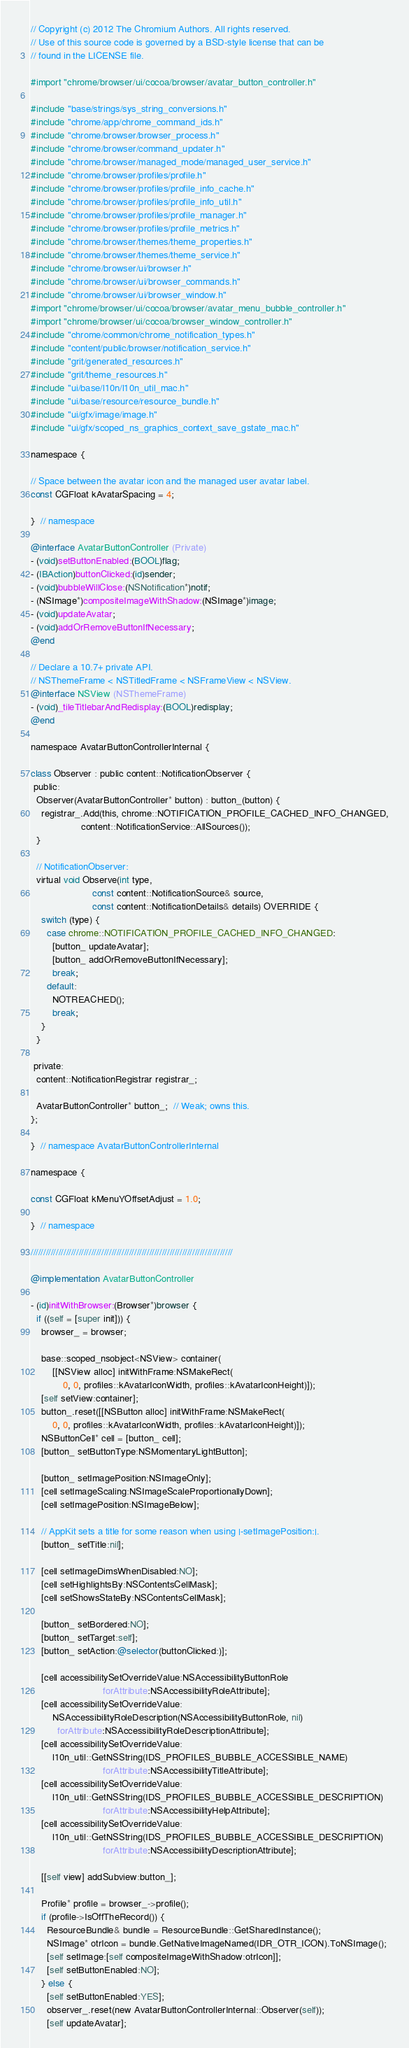<code> <loc_0><loc_0><loc_500><loc_500><_ObjectiveC_>// Copyright (c) 2012 The Chromium Authors. All rights reserved.
// Use of this source code is governed by a BSD-style license that can be
// found in the LICENSE file.

#import "chrome/browser/ui/cocoa/browser/avatar_button_controller.h"

#include "base/strings/sys_string_conversions.h"
#include "chrome/app/chrome_command_ids.h"
#include "chrome/browser/browser_process.h"
#include "chrome/browser/command_updater.h"
#include "chrome/browser/managed_mode/managed_user_service.h"
#include "chrome/browser/profiles/profile.h"
#include "chrome/browser/profiles/profile_info_cache.h"
#include "chrome/browser/profiles/profile_info_util.h"
#include "chrome/browser/profiles/profile_manager.h"
#include "chrome/browser/profiles/profile_metrics.h"
#include "chrome/browser/themes/theme_properties.h"
#include "chrome/browser/themes/theme_service.h"
#include "chrome/browser/ui/browser.h"
#include "chrome/browser/ui/browser_commands.h"
#include "chrome/browser/ui/browser_window.h"
#import "chrome/browser/ui/cocoa/browser/avatar_menu_bubble_controller.h"
#import "chrome/browser/ui/cocoa/browser_window_controller.h"
#include "chrome/common/chrome_notification_types.h"
#include "content/public/browser/notification_service.h"
#include "grit/generated_resources.h"
#include "grit/theme_resources.h"
#include "ui/base/l10n/l10n_util_mac.h"
#include "ui/base/resource/resource_bundle.h"
#include "ui/gfx/image/image.h"
#include "ui/gfx/scoped_ns_graphics_context_save_gstate_mac.h"

namespace {

// Space between the avatar icon and the managed user avatar label.
const CGFloat kAvatarSpacing = 4;

}  // namespace

@interface AvatarButtonController (Private)
- (void)setButtonEnabled:(BOOL)flag;
- (IBAction)buttonClicked:(id)sender;
- (void)bubbleWillClose:(NSNotification*)notif;
- (NSImage*)compositeImageWithShadow:(NSImage*)image;
- (void)updateAvatar;
- (void)addOrRemoveButtonIfNecessary;
@end

// Declare a 10.7+ private API.
// NSThemeFrame < NSTitledFrame < NSFrameView < NSView.
@interface NSView (NSThemeFrame)
- (void)_tileTitlebarAndRedisplay:(BOOL)redisplay;
@end

namespace AvatarButtonControllerInternal {

class Observer : public content::NotificationObserver {
 public:
  Observer(AvatarButtonController* button) : button_(button) {
    registrar_.Add(this, chrome::NOTIFICATION_PROFILE_CACHED_INFO_CHANGED,
                   content::NotificationService::AllSources());
  }

  // NotificationObserver:
  virtual void Observe(int type,
                       const content::NotificationSource& source,
                       const content::NotificationDetails& details) OVERRIDE {
    switch (type) {
      case chrome::NOTIFICATION_PROFILE_CACHED_INFO_CHANGED:
        [button_ updateAvatar];
        [button_ addOrRemoveButtonIfNecessary];
        break;
      default:
        NOTREACHED();
        break;
    }
  }

 private:
  content::NotificationRegistrar registrar_;

  AvatarButtonController* button_;  // Weak; owns this.
};

}  // namespace AvatarButtonControllerInternal

namespace {

const CGFloat kMenuYOffsetAdjust = 1.0;

}  // namespace

////////////////////////////////////////////////////////////////////////////////

@implementation AvatarButtonController

- (id)initWithBrowser:(Browser*)browser {
  if ((self = [super init])) {
    browser_ = browser;

    base::scoped_nsobject<NSView> container(
        [[NSView alloc] initWithFrame:NSMakeRect(
            0, 0, profiles::kAvatarIconWidth, profiles::kAvatarIconHeight)]);
    [self setView:container];
    button_.reset([[NSButton alloc] initWithFrame:NSMakeRect(
        0, 0, profiles::kAvatarIconWidth, profiles::kAvatarIconHeight)]);
    NSButtonCell* cell = [button_ cell];
    [button_ setButtonType:NSMomentaryLightButton];

    [button_ setImagePosition:NSImageOnly];
    [cell setImageScaling:NSImageScaleProportionallyDown];
    [cell setImagePosition:NSImageBelow];

    // AppKit sets a title for some reason when using |-setImagePosition:|.
    [button_ setTitle:nil];

    [cell setImageDimsWhenDisabled:NO];
    [cell setHighlightsBy:NSContentsCellMask];
    [cell setShowsStateBy:NSContentsCellMask];

    [button_ setBordered:NO];
    [button_ setTarget:self];
    [button_ setAction:@selector(buttonClicked:)];

    [cell accessibilitySetOverrideValue:NSAccessibilityButtonRole
                           forAttribute:NSAccessibilityRoleAttribute];
    [cell accessibilitySetOverrideValue:
        NSAccessibilityRoleDescription(NSAccessibilityButtonRole, nil)
          forAttribute:NSAccessibilityRoleDescriptionAttribute];
    [cell accessibilitySetOverrideValue:
        l10n_util::GetNSString(IDS_PROFILES_BUBBLE_ACCESSIBLE_NAME)
                           forAttribute:NSAccessibilityTitleAttribute];
    [cell accessibilitySetOverrideValue:
        l10n_util::GetNSString(IDS_PROFILES_BUBBLE_ACCESSIBLE_DESCRIPTION)
                           forAttribute:NSAccessibilityHelpAttribute];
    [cell accessibilitySetOverrideValue:
        l10n_util::GetNSString(IDS_PROFILES_BUBBLE_ACCESSIBLE_DESCRIPTION)
                           forAttribute:NSAccessibilityDescriptionAttribute];

    [[self view] addSubview:button_];

    Profile* profile = browser_->profile();
    if (profile->IsOffTheRecord()) {
      ResourceBundle& bundle = ResourceBundle::GetSharedInstance();
      NSImage* otrIcon = bundle.GetNativeImageNamed(IDR_OTR_ICON).ToNSImage();
      [self setImage:[self compositeImageWithShadow:otrIcon]];
      [self setButtonEnabled:NO];
    } else {
      [self setButtonEnabled:YES];
      observer_.reset(new AvatarButtonControllerInternal::Observer(self));
      [self updateAvatar];
</code> 